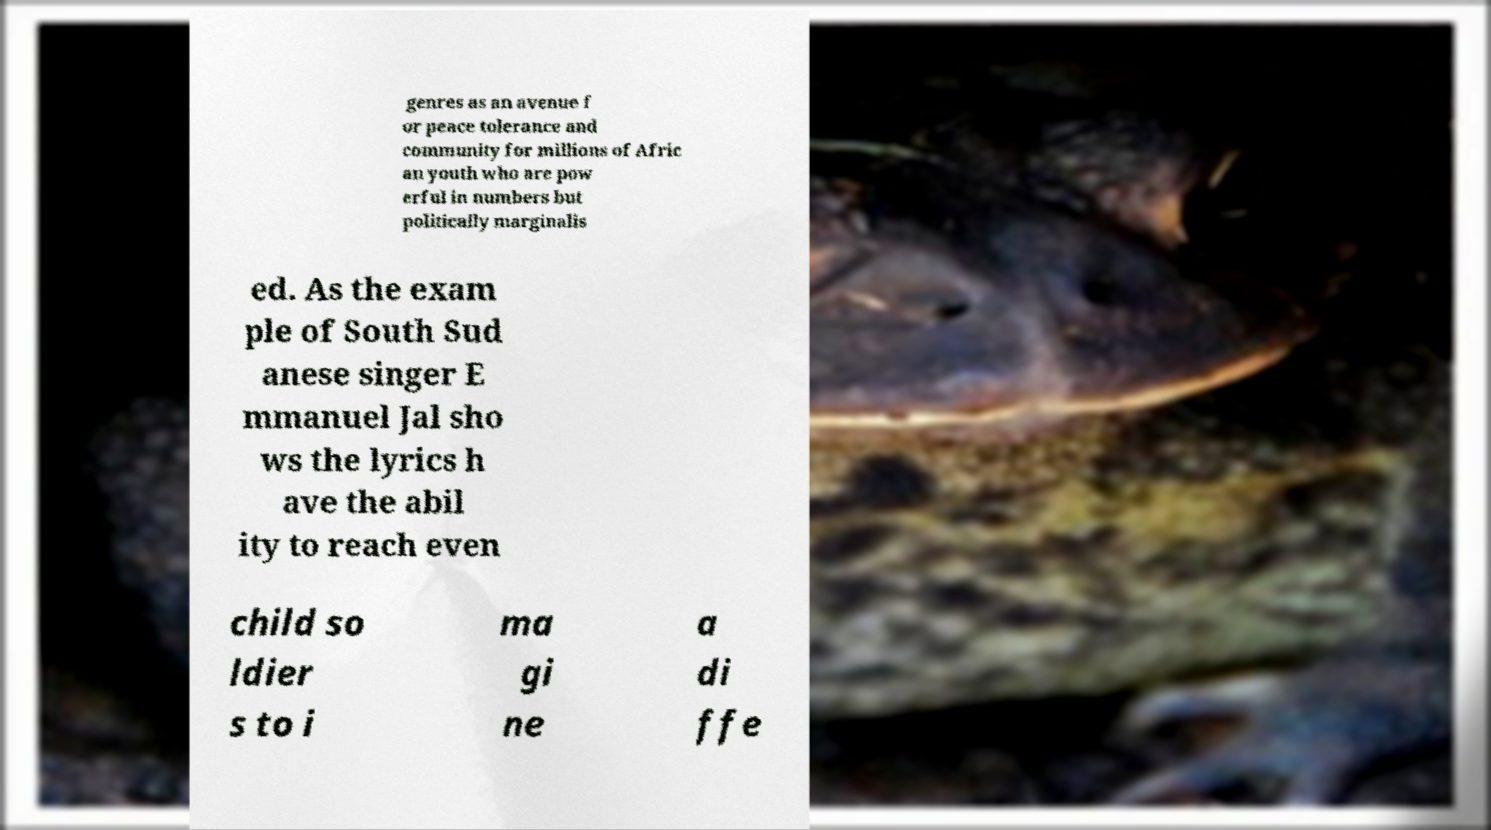Could you extract and type out the text from this image? genres as an avenue f or peace tolerance and community for millions of Afric an youth who are pow erful in numbers but politically marginalis ed. As the exam ple of South Sud anese singer E mmanuel Jal sho ws the lyrics h ave the abil ity to reach even child so ldier s to i ma gi ne a di ffe 